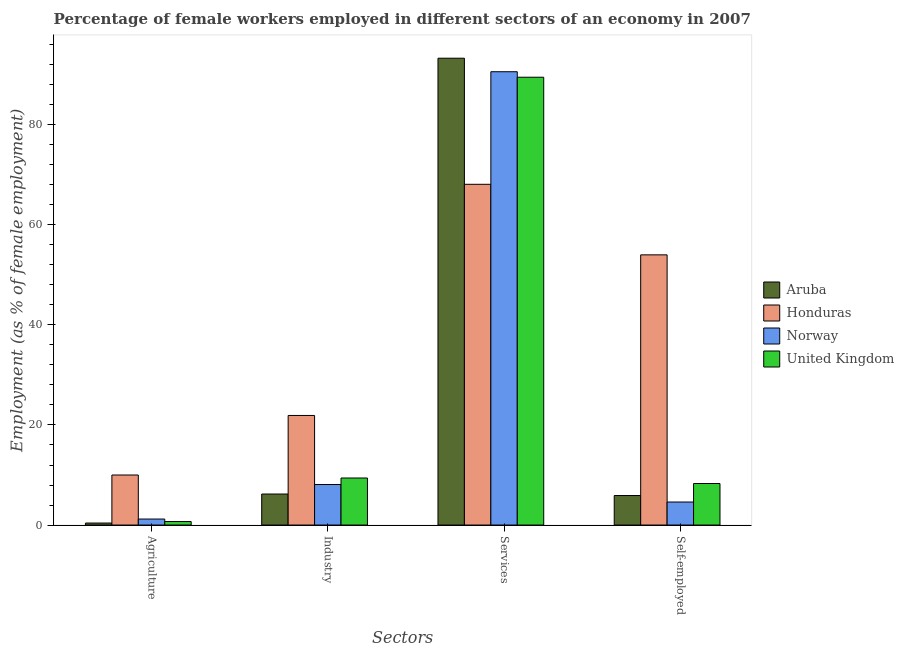How many groups of bars are there?
Provide a short and direct response. 4. How many bars are there on the 4th tick from the right?
Give a very brief answer. 4. What is the label of the 2nd group of bars from the left?
Make the answer very short. Industry. What is the percentage of female workers in services in Aruba?
Give a very brief answer. 93.3. Across all countries, what is the minimum percentage of female workers in industry?
Make the answer very short. 6.2. In which country was the percentage of female workers in industry maximum?
Your answer should be very brief. Honduras. In which country was the percentage of female workers in agriculture minimum?
Give a very brief answer. Aruba. What is the total percentage of female workers in agriculture in the graph?
Your response must be concise. 12.3. What is the difference between the percentage of female workers in agriculture in United Kingdom and that in Honduras?
Your answer should be very brief. -9.3. What is the difference between the percentage of female workers in industry in Aruba and the percentage of female workers in agriculture in United Kingdom?
Offer a very short reply. 5.5. What is the average percentage of female workers in agriculture per country?
Give a very brief answer. 3.08. What is the difference between the percentage of self employed female workers and percentage of female workers in services in Aruba?
Offer a very short reply. -87.4. In how many countries, is the percentage of female workers in services greater than 64 %?
Provide a short and direct response. 4. What is the ratio of the percentage of female workers in services in Honduras to that in Norway?
Your answer should be compact. 0.75. Is the percentage of female workers in services in Aruba less than that in Norway?
Provide a succinct answer. No. What is the difference between the highest and the second highest percentage of female workers in agriculture?
Your answer should be very brief. 8.8. What is the difference between the highest and the lowest percentage of self employed female workers?
Your response must be concise. 49.4. In how many countries, is the percentage of female workers in agriculture greater than the average percentage of female workers in agriculture taken over all countries?
Give a very brief answer. 1. What does the 3rd bar from the left in Services represents?
Your answer should be very brief. Norway. What does the 1st bar from the right in Services represents?
Offer a terse response. United Kingdom. Is it the case that in every country, the sum of the percentage of female workers in agriculture and percentage of female workers in industry is greater than the percentage of female workers in services?
Offer a terse response. No. How many countries are there in the graph?
Your answer should be compact. 4. What is the difference between two consecutive major ticks on the Y-axis?
Provide a succinct answer. 20. Does the graph contain any zero values?
Give a very brief answer. No. How many legend labels are there?
Make the answer very short. 4. How are the legend labels stacked?
Provide a succinct answer. Vertical. What is the title of the graph?
Give a very brief answer. Percentage of female workers employed in different sectors of an economy in 2007. What is the label or title of the X-axis?
Make the answer very short. Sectors. What is the label or title of the Y-axis?
Your answer should be compact. Employment (as % of female employment). What is the Employment (as % of female employment) of Aruba in Agriculture?
Offer a very short reply. 0.4. What is the Employment (as % of female employment) in Norway in Agriculture?
Keep it short and to the point. 1.2. What is the Employment (as % of female employment) of United Kingdom in Agriculture?
Keep it short and to the point. 0.7. What is the Employment (as % of female employment) of Aruba in Industry?
Offer a terse response. 6.2. What is the Employment (as % of female employment) of Honduras in Industry?
Ensure brevity in your answer.  21.9. What is the Employment (as % of female employment) in Norway in Industry?
Make the answer very short. 8.1. What is the Employment (as % of female employment) in United Kingdom in Industry?
Provide a short and direct response. 9.4. What is the Employment (as % of female employment) of Aruba in Services?
Provide a short and direct response. 93.3. What is the Employment (as % of female employment) in Honduras in Services?
Make the answer very short. 68.1. What is the Employment (as % of female employment) of Norway in Services?
Offer a very short reply. 90.6. What is the Employment (as % of female employment) of United Kingdom in Services?
Make the answer very short. 89.5. What is the Employment (as % of female employment) in Aruba in Self-employed?
Keep it short and to the point. 5.9. What is the Employment (as % of female employment) in Honduras in Self-employed?
Keep it short and to the point. 54. What is the Employment (as % of female employment) of Norway in Self-employed?
Your answer should be very brief. 4.6. What is the Employment (as % of female employment) of United Kingdom in Self-employed?
Your response must be concise. 8.3. Across all Sectors, what is the maximum Employment (as % of female employment) of Aruba?
Provide a short and direct response. 93.3. Across all Sectors, what is the maximum Employment (as % of female employment) of Honduras?
Offer a terse response. 68.1. Across all Sectors, what is the maximum Employment (as % of female employment) of Norway?
Provide a short and direct response. 90.6. Across all Sectors, what is the maximum Employment (as % of female employment) in United Kingdom?
Offer a terse response. 89.5. Across all Sectors, what is the minimum Employment (as % of female employment) in Aruba?
Keep it short and to the point. 0.4. Across all Sectors, what is the minimum Employment (as % of female employment) in Norway?
Give a very brief answer. 1.2. Across all Sectors, what is the minimum Employment (as % of female employment) of United Kingdom?
Make the answer very short. 0.7. What is the total Employment (as % of female employment) in Aruba in the graph?
Provide a succinct answer. 105.8. What is the total Employment (as % of female employment) in Honduras in the graph?
Your answer should be very brief. 154. What is the total Employment (as % of female employment) of Norway in the graph?
Give a very brief answer. 104.5. What is the total Employment (as % of female employment) of United Kingdom in the graph?
Your answer should be compact. 107.9. What is the difference between the Employment (as % of female employment) of Norway in Agriculture and that in Industry?
Keep it short and to the point. -6.9. What is the difference between the Employment (as % of female employment) of Aruba in Agriculture and that in Services?
Your response must be concise. -92.9. What is the difference between the Employment (as % of female employment) in Honduras in Agriculture and that in Services?
Provide a short and direct response. -58.1. What is the difference between the Employment (as % of female employment) in Norway in Agriculture and that in Services?
Make the answer very short. -89.4. What is the difference between the Employment (as % of female employment) in United Kingdom in Agriculture and that in Services?
Offer a very short reply. -88.8. What is the difference between the Employment (as % of female employment) in Honduras in Agriculture and that in Self-employed?
Keep it short and to the point. -44. What is the difference between the Employment (as % of female employment) in United Kingdom in Agriculture and that in Self-employed?
Your answer should be very brief. -7.6. What is the difference between the Employment (as % of female employment) of Aruba in Industry and that in Services?
Provide a succinct answer. -87.1. What is the difference between the Employment (as % of female employment) of Honduras in Industry and that in Services?
Ensure brevity in your answer.  -46.2. What is the difference between the Employment (as % of female employment) in Norway in Industry and that in Services?
Offer a terse response. -82.5. What is the difference between the Employment (as % of female employment) of United Kingdom in Industry and that in Services?
Offer a terse response. -80.1. What is the difference between the Employment (as % of female employment) in Honduras in Industry and that in Self-employed?
Provide a short and direct response. -32.1. What is the difference between the Employment (as % of female employment) of Norway in Industry and that in Self-employed?
Provide a succinct answer. 3.5. What is the difference between the Employment (as % of female employment) of United Kingdom in Industry and that in Self-employed?
Ensure brevity in your answer.  1.1. What is the difference between the Employment (as % of female employment) of Aruba in Services and that in Self-employed?
Offer a very short reply. 87.4. What is the difference between the Employment (as % of female employment) in Norway in Services and that in Self-employed?
Provide a succinct answer. 86. What is the difference between the Employment (as % of female employment) of United Kingdom in Services and that in Self-employed?
Provide a short and direct response. 81.2. What is the difference between the Employment (as % of female employment) in Aruba in Agriculture and the Employment (as % of female employment) in Honduras in Industry?
Make the answer very short. -21.5. What is the difference between the Employment (as % of female employment) of Honduras in Agriculture and the Employment (as % of female employment) of Norway in Industry?
Make the answer very short. 1.9. What is the difference between the Employment (as % of female employment) in Aruba in Agriculture and the Employment (as % of female employment) in Honduras in Services?
Offer a very short reply. -67.7. What is the difference between the Employment (as % of female employment) in Aruba in Agriculture and the Employment (as % of female employment) in Norway in Services?
Your response must be concise. -90.2. What is the difference between the Employment (as % of female employment) of Aruba in Agriculture and the Employment (as % of female employment) of United Kingdom in Services?
Provide a succinct answer. -89.1. What is the difference between the Employment (as % of female employment) in Honduras in Agriculture and the Employment (as % of female employment) in Norway in Services?
Make the answer very short. -80.6. What is the difference between the Employment (as % of female employment) of Honduras in Agriculture and the Employment (as % of female employment) of United Kingdom in Services?
Ensure brevity in your answer.  -79.5. What is the difference between the Employment (as % of female employment) of Norway in Agriculture and the Employment (as % of female employment) of United Kingdom in Services?
Offer a very short reply. -88.3. What is the difference between the Employment (as % of female employment) in Aruba in Agriculture and the Employment (as % of female employment) in Honduras in Self-employed?
Keep it short and to the point. -53.6. What is the difference between the Employment (as % of female employment) of Aruba in Agriculture and the Employment (as % of female employment) of United Kingdom in Self-employed?
Your answer should be compact. -7.9. What is the difference between the Employment (as % of female employment) of Honduras in Agriculture and the Employment (as % of female employment) of Norway in Self-employed?
Ensure brevity in your answer.  5.4. What is the difference between the Employment (as % of female employment) of Honduras in Agriculture and the Employment (as % of female employment) of United Kingdom in Self-employed?
Your answer should be very brief. 1.7. What is the difference between the Employment (as % of female employment) of Norway in Agriculture and the Employment (as % of female employment) of United Kingdom in Self-employed?
Your response must be concise. -7.1. What is the difference between the Employment (as % of female employment) of Aruba in Industry and the Employment (as % of female employment) of Honduras in Services?
Offer a terse response. -61.9. What is the difference between the Employment (as % of female employment) of Aruba in Industry and the Employment (as % of female employment) of Norway in Services?
Your response must be concise. -84.4. What is the difference between the Employment (as % of female employment) in Aruba in Industry and the Employment (as % of female employment) in United Kingdom in Services?
Your answer should be compact. -83.3. What is the difference between the Employment (as % of female employment) in Honduras in Industry and the Employment (as % of female employment) in Norway in Services?
Your answer should be compact. -68.7. What is the difference between the Employment (as % of female employment) in Honduras in Industry and the Employment (as % of female employment) in United Kingdom in Services?
Provide a short and direct response. -67.6. What is the difference between the Employment (as % of female employment) in Norway in Industry and the Employment (as % of female employment) in United Kingdom in Services?
Make the answer very short. -81.4. What is the difference between the Employment (as % of female employment) of Aruba in Industry and the Employment (as % of female employment) of Honduras in Self-employed?
Make the answer very short. -47.8. What is the difference between the Employment (as % of female employment) of Honduras in Industry and the Employment (as % of female employment) of United Kingdom in Self-employed?
Keep it short and to the point. 13.6. What is the difference between the Employment (as % of female employment) in Aruba in Services and the Employment (as % of female employment) in Honduras in Self-employed?
Keep it short and to the point. 39.3. What is the difference between the Employment (as % of female employment) in Aruba in Services and the Employment (as % of female employment) in Norway in Self-employed?
Make the answer very short. 88.7. What is the difference between the Employment (as % of female employment) of Honduras in Services and the Employment (as % of female employment) of Norway in Self-employed?
Give a very brief answer. 63.5. What is the difference between the Employment (as % of female employment) of Honduras in Services and the Employment (as % of female employment) of United Kingdom in Self-employed?
Provide a succinct answer. 59.8. What is the difference between the Employment (as % of female employment) of Norway in Services and the Employment (as % of female employment) of United Kingdom in Self-employed?
Provide a short and direct response. 82.3. What is the average Employment (as % of female employment) of Aruba per Sectors?
Offer a terse response. 26.45. What is the average Employment (as % of female employment) of Honduras per Sectors?
Offer a very short reply. 38.5. What is the average Employment (as % of female employment) of Norway per Sectors?
Keep it short and to the point. 26.12. What is the average Employment (as % of female employment) in United Kingdom per Sectors?
Keep it short and to the point. 26.98. What is the difference between the Employment (as % of female employment) in Aruba and Employment (as % of female employment) in Honduras in Agriculture?
Your response must be concise. -9.6. What is the difference between the Employment (as % of female employment) in Honduras and Employment (as % of female employment) in United Kingdom in Agriculture?
Give a very brief answer. 9.3. What is the difference between the Employment (as % of female employment) of Norway and Employment (as % of female employment) of United Kingdom in Agriculture?
Your answer should be very brief. 0.5. What is the difference between the Employment (as % of female employment) in Aruba and Employment (as % of female employment) in Honduras in Industry?
Offer a terse response. -15.7. What is the difference between the Employment (as % of female employment) of Aruba and Employment (as % of female employment) of United Kingdom in Industry?
Make the answer very short. -3.2. What is the difference between the Employment (as % of female employment) in Honduras and Employment (as % of female employment) in Norway in Industry?
Your answer should be very brief. 13.8. What is the difference between the Employment (as % of female employment) in Honduras and Employment (as % of female employment) in United Kingdom in Industry?
Ensure brevity in your answer.  12.5. What is the difference between the Employment (as % of female employment) in Aruba and Employment (as % of female employment) in Honduras in Services?
Ensure brevity in your answer.  25.2. What is the difference between the Employment (as % of female employment) in Aruba and Employment (as % of female employment) in Norway in Services?
Your response must be concise. 2.7. What is the difference between the Employment (as % of female employment) in Aruba and Employment (as % of female employment) in United Kingdom in Services?
Give a very brief answer. 3.8. What is the difference between the Employment (as % of female employment) in Honduras and Employment (as % of female employment) in Norway in Services?
Your answer should be compact. -22.5. What is the difference between the Employment (as % of female employment) in Honduras and Employment (as % of female employment) in United Kingdom in Services?
Keep it short and to the point. -21.4. What is the difference between the Employment (as % of female employment) in Norway and Employment (as % of female employment) in United Kingdom in Services?
Keep it short and to the point. 1.1. What is the difference between the Employment (as % of female employment) of Aruba and Employment (as % of female employment) of Honduras in Self-employed?
Your response must be concise. -48.1. What is the difference between the Employment (as % of female employment) of Aruba and Employment (as % of female employment) of United Kingdom in Self-employed?
Your response must be concise. -2.4. What is the difference between the Employment (as % of female employment) in Honduras and Employment (as % of female employment) in Norway in Self-employed?
Provide a short and direct response. 49.4. What is the difference between the Employment (as % of female employment) in Honduras and Employment (as % of female employment) in United Kingdom in Self-employed?
Ensure brevity in your answer.  45.7. What is the difference between the Employment (as % of female employment) of Norway and Employment (as % of female employment) of United Kingdom in Self-employed?
Your answer should be very brief. -3.7. What is the ratio of the Employment (as % of female employment) in Aruba in Agriculture to that in Industry?
Keep it short and to the point. 0.06. What is the ratio of the Employment (as % of female employment) of Honduras in Agriculture to that in Industry?
Your answer should be very brief. 0.46. What is the ratio of the Employment (as % of female employment) in Norway in Agriculture to that in Industry?
Ensure brevity in your answer.  0.15. What is the ratio of the Employment (as % of female employment) in United Kingdom in Agriculture to that in Industry?
Make the answer very short. 0.07. What is the ratio of the Employment (as % of female employment) in Aruba in Agriculture to that in Services?
Keep it short and to the point. 0. What is the ratio of the Employment (as % of female employment) in Honduras in Agriculture to that in Services?
Provide a succinct answer. 0.15. What is the ratio of the Employment (as % of female employment) of Norway in Agriculture to that in Services?
Make the answer very short. 0.01. What is the ratio of the Employment (as % of female employment) of United Kingdom in Agriculture to that in Services?
Provide a succinct answer. 0.01. What is the ratio of the Employment (as % of female employment) in Aruba in Agriculture to that in Self-employed?
Make the answer very short. 0.07. What is the ratio of the Employment (as % of female employment) of Honduras in Agriculture to that in Self-employed?
Offer a terse response. 0.19. What is the ratio of the Employment (as % of female employment) of Norway in Agriculture to that in Self-employed?
Your answer should be very brief. 0.26. What is the ratio of the Employment (as % of female employment) in United Kingdom in Agriculture to that in Self-employed?
Ensure brevity in your answer.  0.08. What is the ratio of the Employment (as % of female employment) of Aruba in Industry to that in Services?
Provide a short and direct response. 0.07. What is the ratio of the Employment (as % of female employment) in Honduras in Industry to that in Services?
Give a very brief answer. 0.32. What is the ratio of the Employment (as % of female employment) in Norway in Industry to that in Services?
Offer a terse response. 0.09. What is the ratio of the Employment (as % of female employment) of United Kingdom in Industry to that in Services?
Provide a succinct answer. 0.1. What is the ratio of the Employment (as % of female employment) of Aruba in Industry to that in Self-employed?
Your answer should be very brief. 1.05. What is the ratio of the Employment (as % of female employment) in Honduras in Industry to that in Self-employed?
Offer a very short reply. 0.41. What is the ratio of the Employment (as % of female employment) in Norway in Industry to that in Self-employed?
Offer a terse response. 1.76. What is the ratio of the Employment (as % of female employment) of United Kingdom in Industry to that in Self-employed?
Ensure brevity in your answer.  1.13. What is the ratio of the Employment (as % of female employment) in Aruba in Services to that in Self-employed?
Keep it short and to the point. 15.81. What is the ratio of the Employment (as % of female employment) in Honduras in Services to that in Self-employed?
Your answer should be compact. 1.26. What is the ratio of the Employment (as % of female employment) in Norway in Services to that in Self-employed?
Your response must be concise. 19.7. What is the ratio of the Employment (as % of female employment) in United Kingdom in Services to that in Self-employed?
Provide a succinct answer. 10.78. What is the difference between the highest and the second highest Employment (as % of female employment) of Aruba?
Your answer should be compact. 87.1. What is the difference between the highest and the second highest Employment (as % of female employment) in Honduras?
Offer a very short reply. 14.1. What is the difference between the highest and the second highest Employment (as % of female employment) of Norway?
Give a very brief answer. 82.5. What is the difference between the highest and the second highest Employment (as % of female employment) of United Kingdom?
Offer a terse response. 80.1. What is the difference between the highest and the lowest Employment (as % of female employment) in Aruba?
Provide a succinct answer. 92.9. What is the difference between the highest and the lowest Employment (as % of female employment) in Honduras?
Make the answer very short. 58.1. What is the difference between the highest and the lowest Employment (as % of female employment) in Norway?
Offer a terse response. 89.4. What is the difference between the highest and the lowest Employment (as % of female employment) of United Kingdom?
Keep it short and to the point. 88.8. 